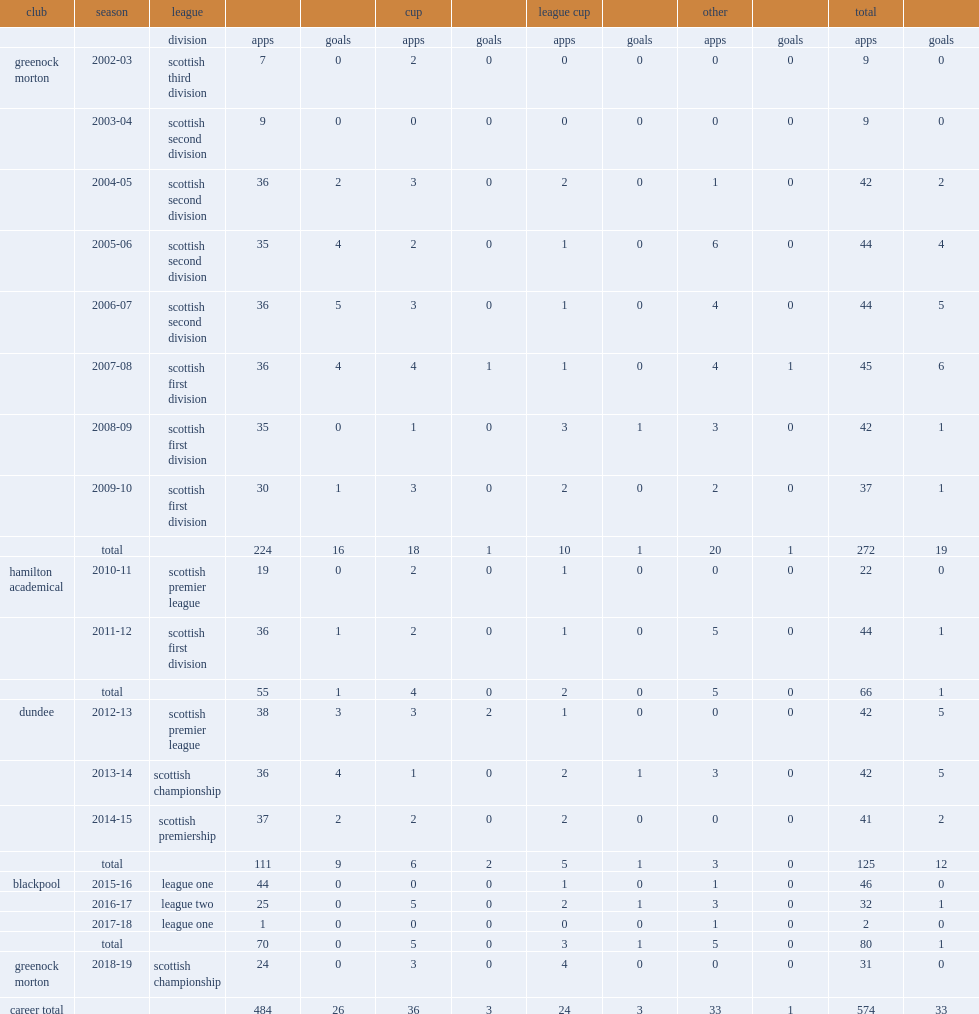How many goals did jim mcalister score for dundee totally? 12.0. 